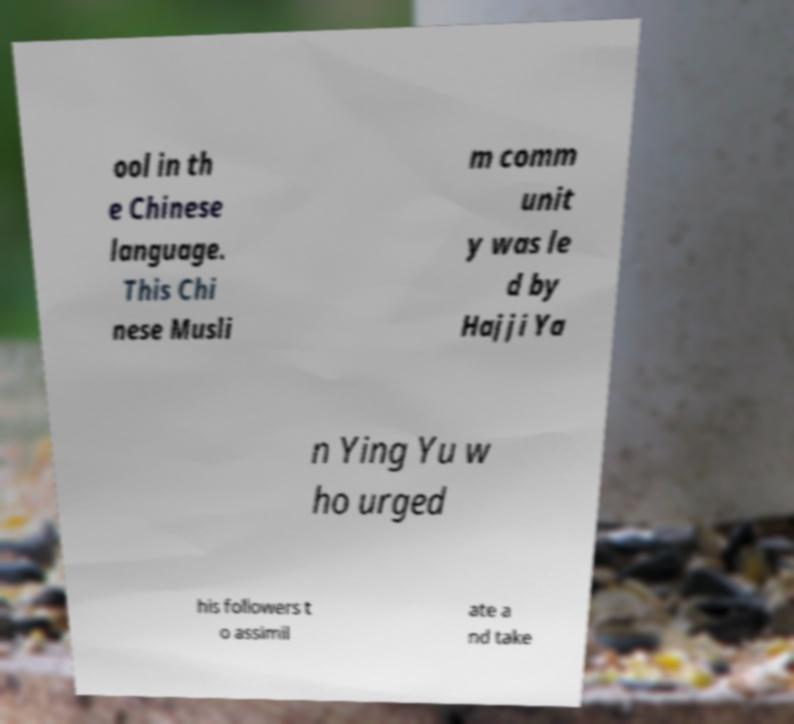I need the written content from this picture converted into text. Can you do that? ool in th e Chinese language. This Chi nese Musli m comm unit y was le d by Hajji Ya n Ying Yu w ho urged his followers t o assimil ate a nd take 